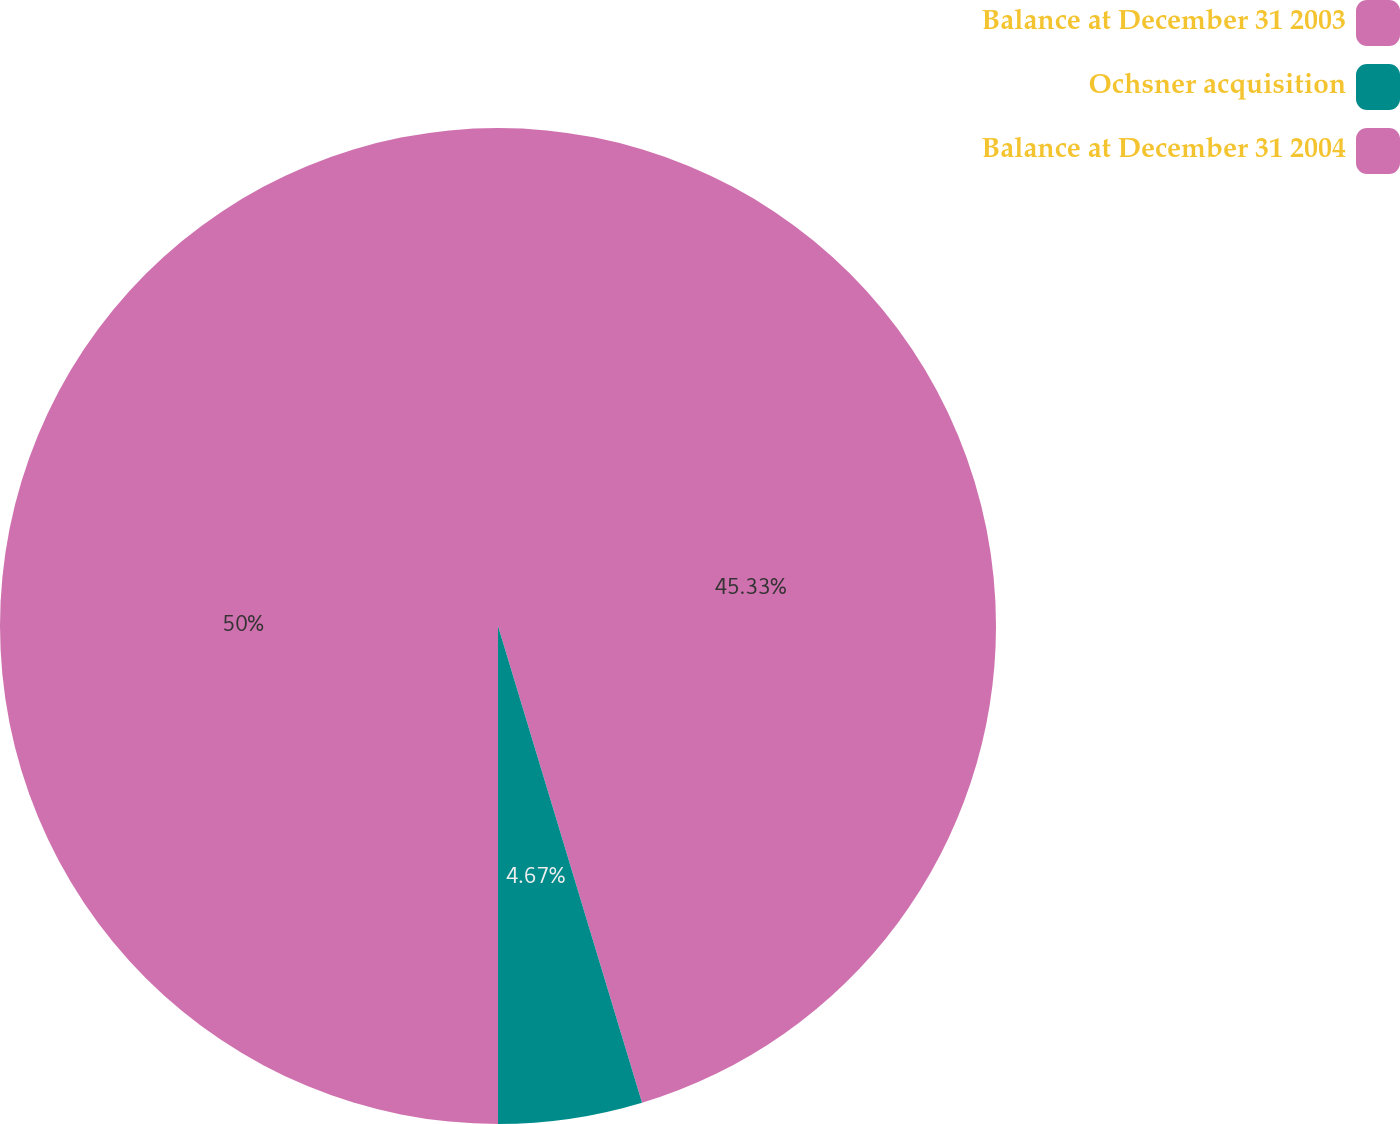Convert chart. <chart><loc_0><loc_0><loc_500><loc_500><pie_chart><fcel>Balance at December 31 2003<fcel>Ochsner acquisition<fcel>Balance at December 31 2004<nl><fcel>45.33%<fcel>4.67%<fcel>50.0%<nl></chart> 